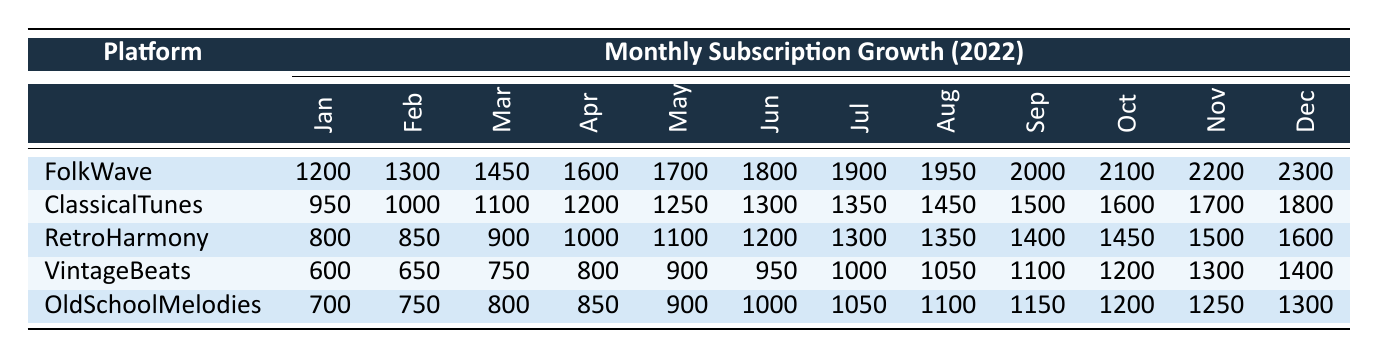What platform had the highest subscription growth in December? By looking at the December values, FolkWave has 2300, ClassicalTunes has 1800, RetroHarmony has 1600, VintageBeats has 1400, and OldSchoolMelodies has 1300. Comparing these values, FolkWave has the highest number.
Answer: FolkWave What was the total subscription growth for VintageBeats over the year? To find the total, we add the monthly values for VintageBeats: 600 + 650 + 750 + 800 + 900 + 950 + 1000 + 1050 + 1100 + 1200 + 1300 + 1400 =  11,800.
Answer: 11800 Did any platform have a consistent monthly increase in subscription growth? Observing the data, we can see that all platforms show a consistent increase every month. Each month’s growth is greater than the previous month.
Answer: Yes What was the average monthly subscription growth for FolkWave in 2022? Adding the values for FolkWave gives 1200 + 1300 + 1450 + 1600 + 1700 + 1800 + 1900 + 1950 + 2000 + 2100 + 2200 + 2300 = 22,200. There are 12 months, so the average is 22,200 / 12 = 1850.
Answer: 1850 Which platform had the lowest subscription growth in January? The January values are: FolkWave 1200, ClassicalTunes 950, RetroHarmony 800, VintageBeats 600, OldSchoolMelodies 700. The lowest is RetroHarmony at 800.
Answer: RetroHarmony How much higher was the October subscription growth for ClassicalTunes compared to VintageBeats? The October value for ClassicalTunes is 1600 and for VintageBeats is 1200. The difference is 1600 - 1200 = 400.
Answer: 400 What was the percentage growth from January to December for OldSchoolMelodies? The January value for OldSchoolMelodies is 700 and the December value is 1300. The growth is 1300 - 700 = 600. The percentage growth is (600 / 700) * 100 = 85.71%.
Answer: 85.71% Did FolkWave grow by more than 1000 subscriptions from January to July? FolkWave's January value is 1200, and the July value is 1900. The difference is 1900 - 1200 = 700, which is less than 1000.
Answer: No What was the overall trend in subscription growth for all platforms throughout the year? Each platform shows a consistent upward trend with increasing monthly subscriptions from January to December, indicating a growing interest in all platforms.
Answer: Growth trend is upward 